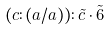<formula> <loc_0><loc_0><loc_500><loc_500>( c \colon ( a / a ) ) \colon \tilde { c } \cdot \tilde { 6 }</formula> 